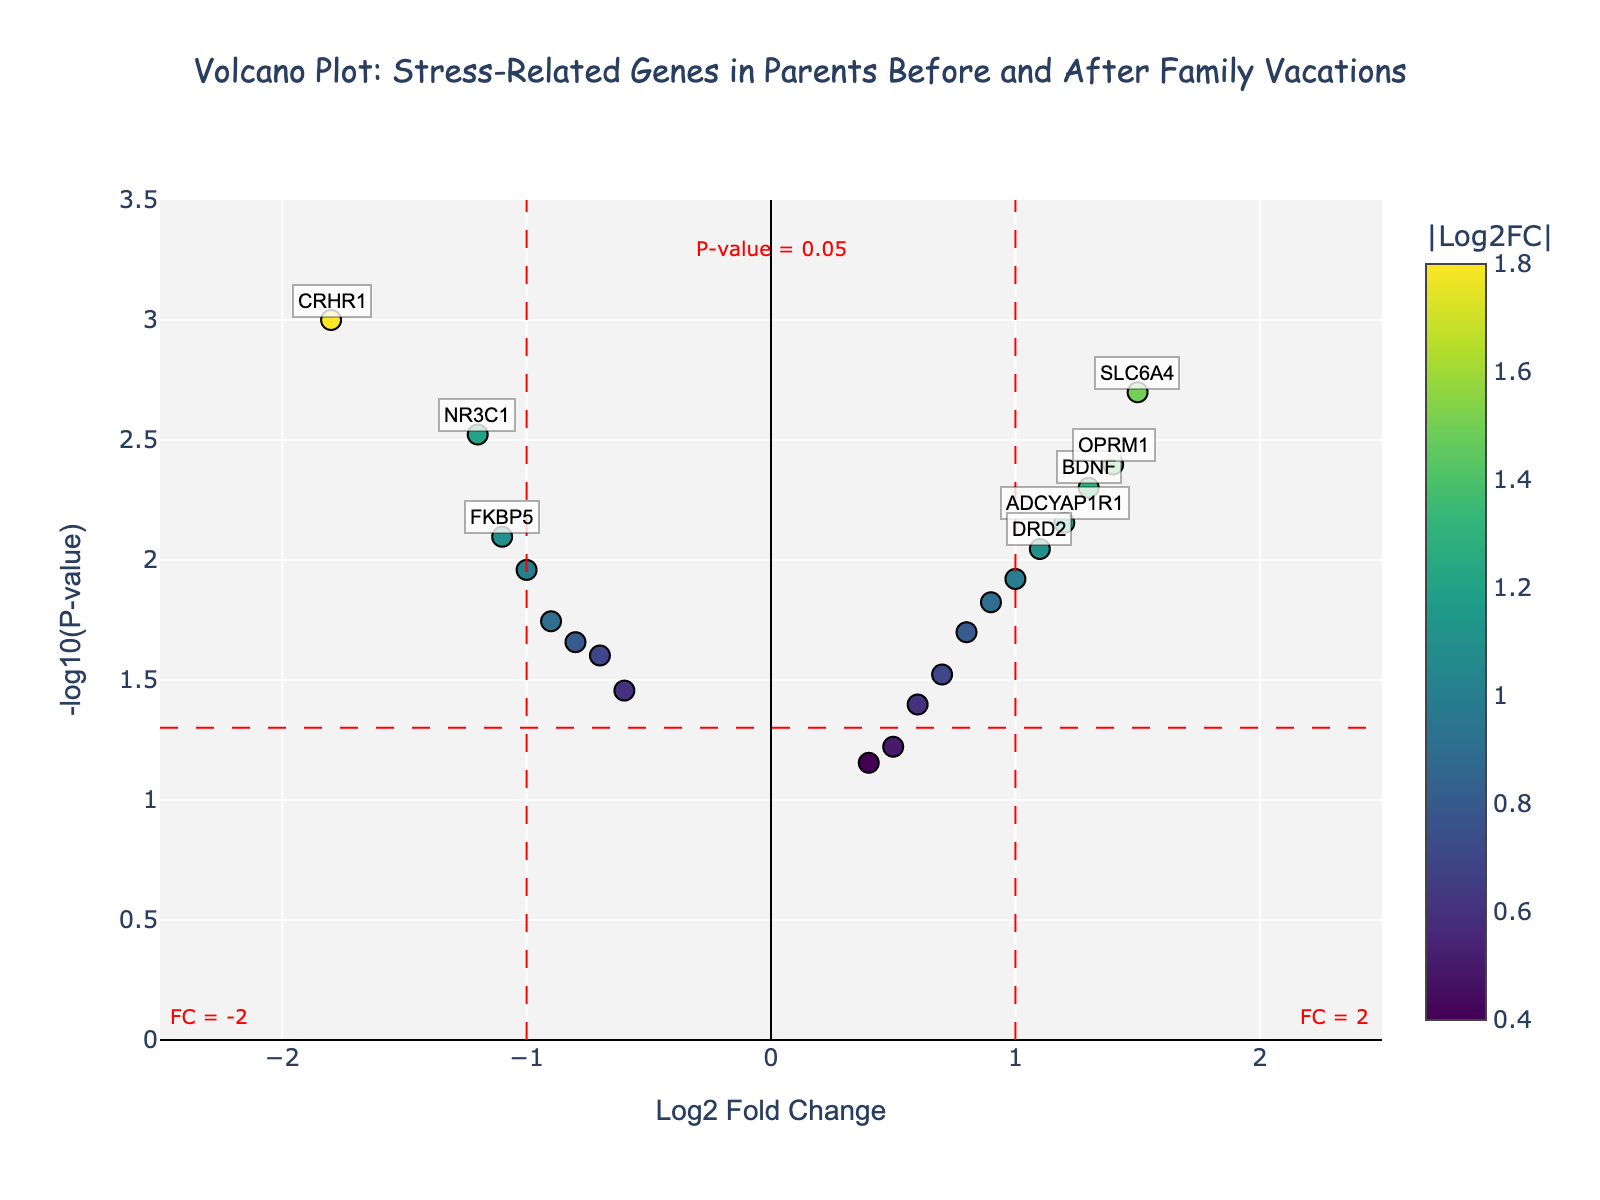what is the title of the figure? The title is mentioned at the top of the figure. It states the main focus of the plot.
Answer: Volcano Plot: Stress-Related Genes in Parents Before and After Family Vacations how many genes have labels? By counting the annotations on the plot, we can determine the number of genes that are labeled.
Answer: 10 which gene has the highest Log2 Fold Change? By locating the point furthest to the right along the x-axis, we find the gene with the highest Log2 Fold Change.
Answer: SLC6A4 which gene has the lowest Log2 Fold Change? By locating the point furthest to the left along the x-axis, we find the gene with the lowest Log2 Fold Change.
Answer: CRHR1 which gene has the lowest P-value? By identifying the point that is the highest on the y-axis, we find the gene with the lowest P-value.
Answer: CRHR1 how many genes have a P-value less than 0.05? By counting all the points above the horizontal red line representing a P-value threshold of 0.05, we can determine this number.
Answer: 15 what is the correlation between Log2 Fold Change and -log10(P-value)? To answer this, observe whether there is any clear trend or pattern between the two axes on the scatter plot.
Answer: Not clearly correlated which genes are both significantly upregulated and downregulated? Significant upregulation is indicated by being right of the vertical red line with positive Log2 Fold Change and above the horizontal red line. Significant downregulation is found left of the vertical red line with negative Log2 Fold Change and above the horizontal red line.
Answer: Upregulated: SLC6A4, BDNF, OPRM1, DRD2; Downregulated: CRHR1, NR3C1, FKBP5, CACNA1C what is the significance threshold for p-value indicated on the plot? The threshold for significance is marked by the horizontal red dashed line, and it is labelled on the plot.
Answer: 0.05 